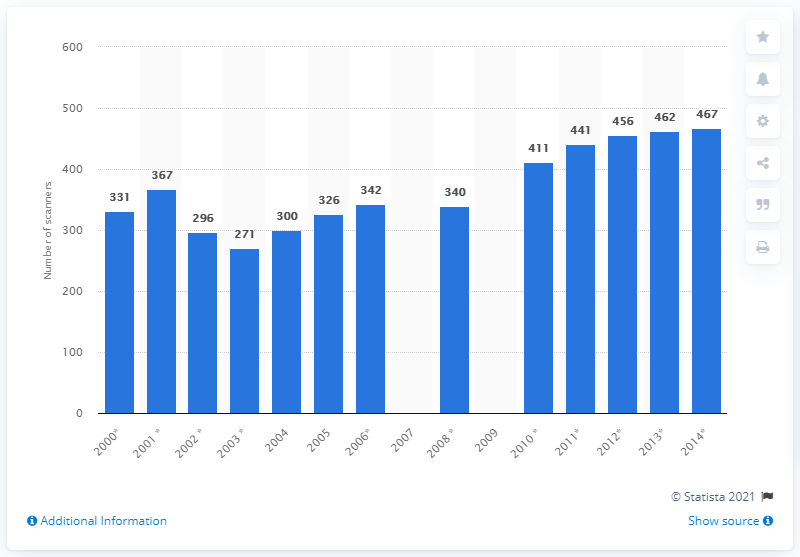Indicate a few pertinent items in this graphic. In 2014, there were 467 MRI scanners in the United Kingdom. 